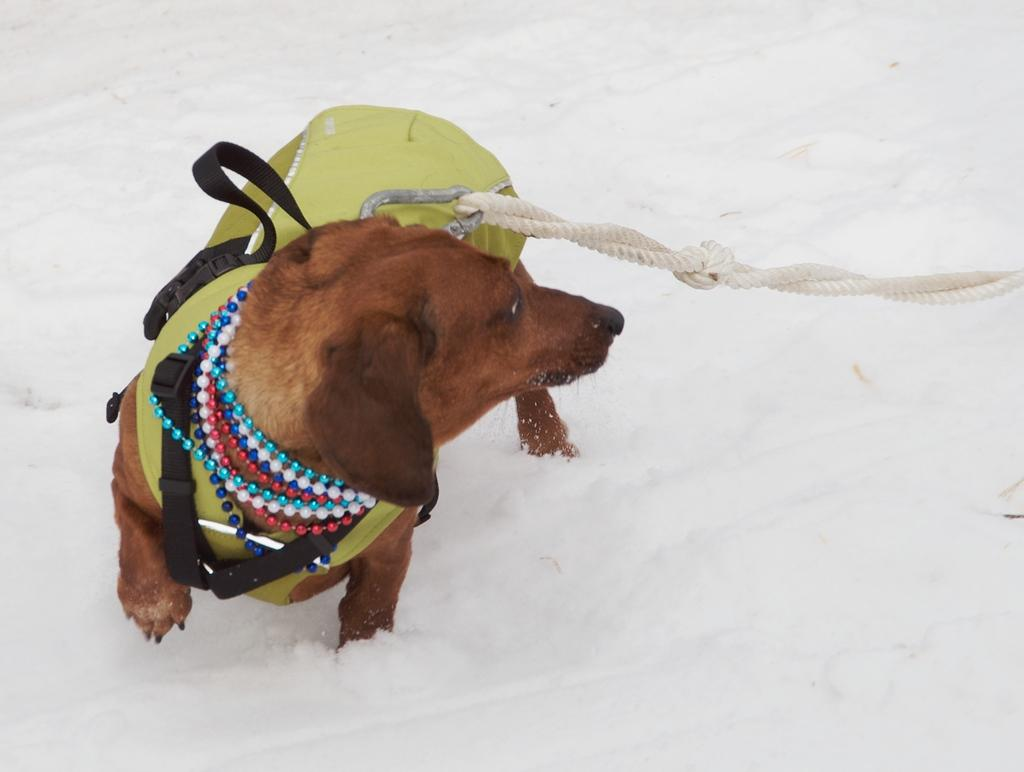What animal is present in the image? There is a dog in the image. What is attached to the dog? The dog has a hook and a rope. What type of toothpaste is the dog using in the image? There is no toothpaste present in the image, and the dog is not using any toothpaste. 